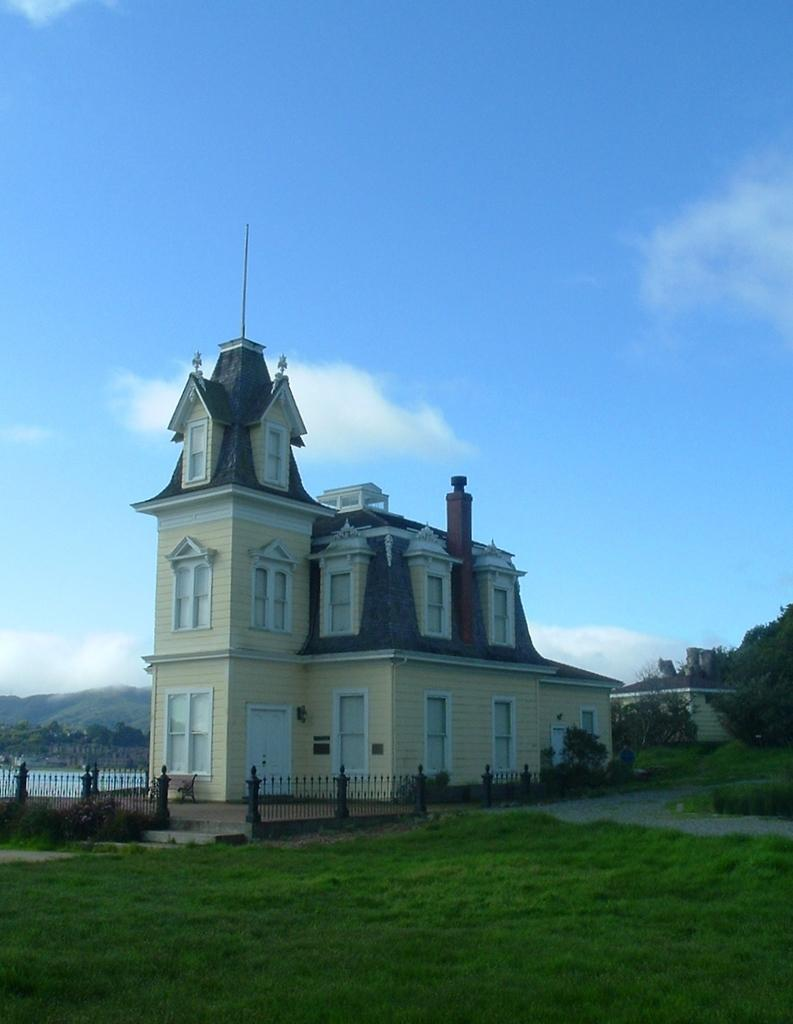What is the main structure in the center of the image? There is a building in the center of the image. What type of natural environment is visible at the bottom of the image? There is grassland at the bottom side of the image. What can be seen on the right side of the image? There are trees on the right side of the image. What is present on the left side of the image? There are trees on the left side of the image. How many basketballs can be seen in the image? There are no basketballs present in the image. 